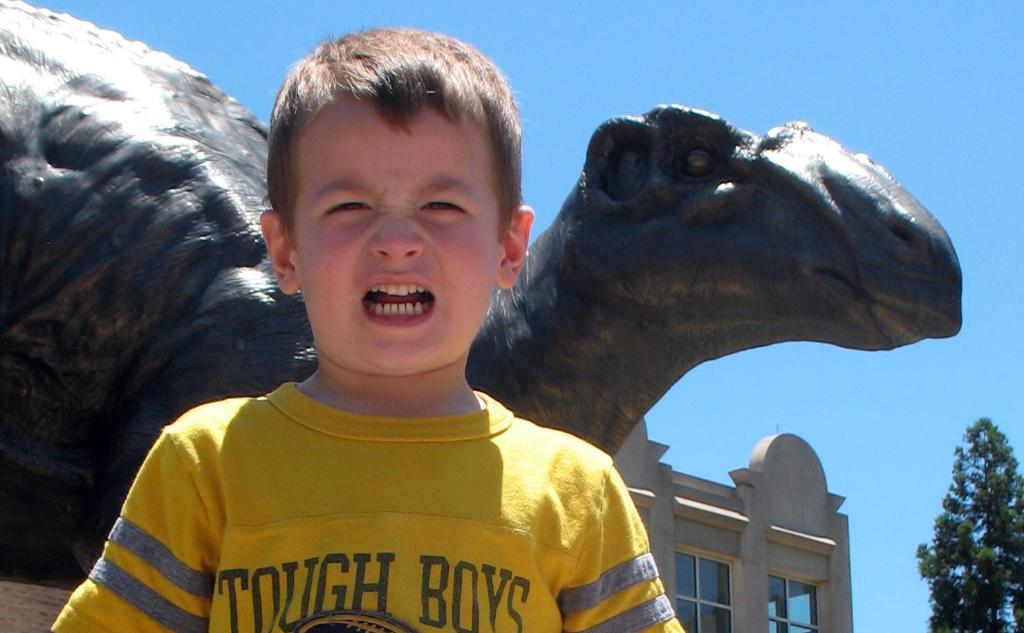Who is present in the image? There is a boy in the image. What can be seen in the background of the image? There is a dinosaur statue, a building, windows, a tree, and the sky visible in the background of the image. What type of furniture can be seen in the image? There is no furniture present in the image. Can you describe the airplane visible in the image? There is no airplane present in the image. 